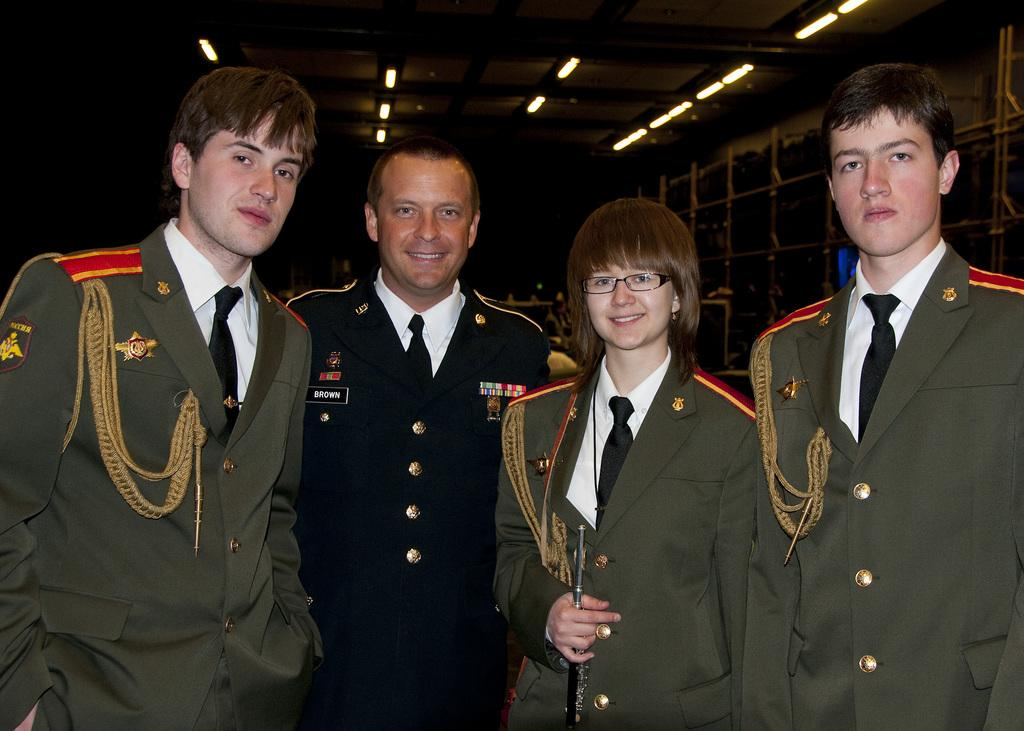How many people are in the foreground of the picture? There are four people in the foreground of the picture. What are the people wearing in the image? The people are wearing military uniforms. What can be seen in the background of the image? There are racks in the background of the image. What type of lighting is present in the image? There are lights on the ceiling in the image. What type of machine is being compared by the people in the image? There is no machine being compared by the people in the image; they are wearing military uniforms. What sense is being stimulated by the lights on the ceiling in the image? The lights on the ceiling in the image are not designed to stimulate a specific sense; they are simply providing illumination. 